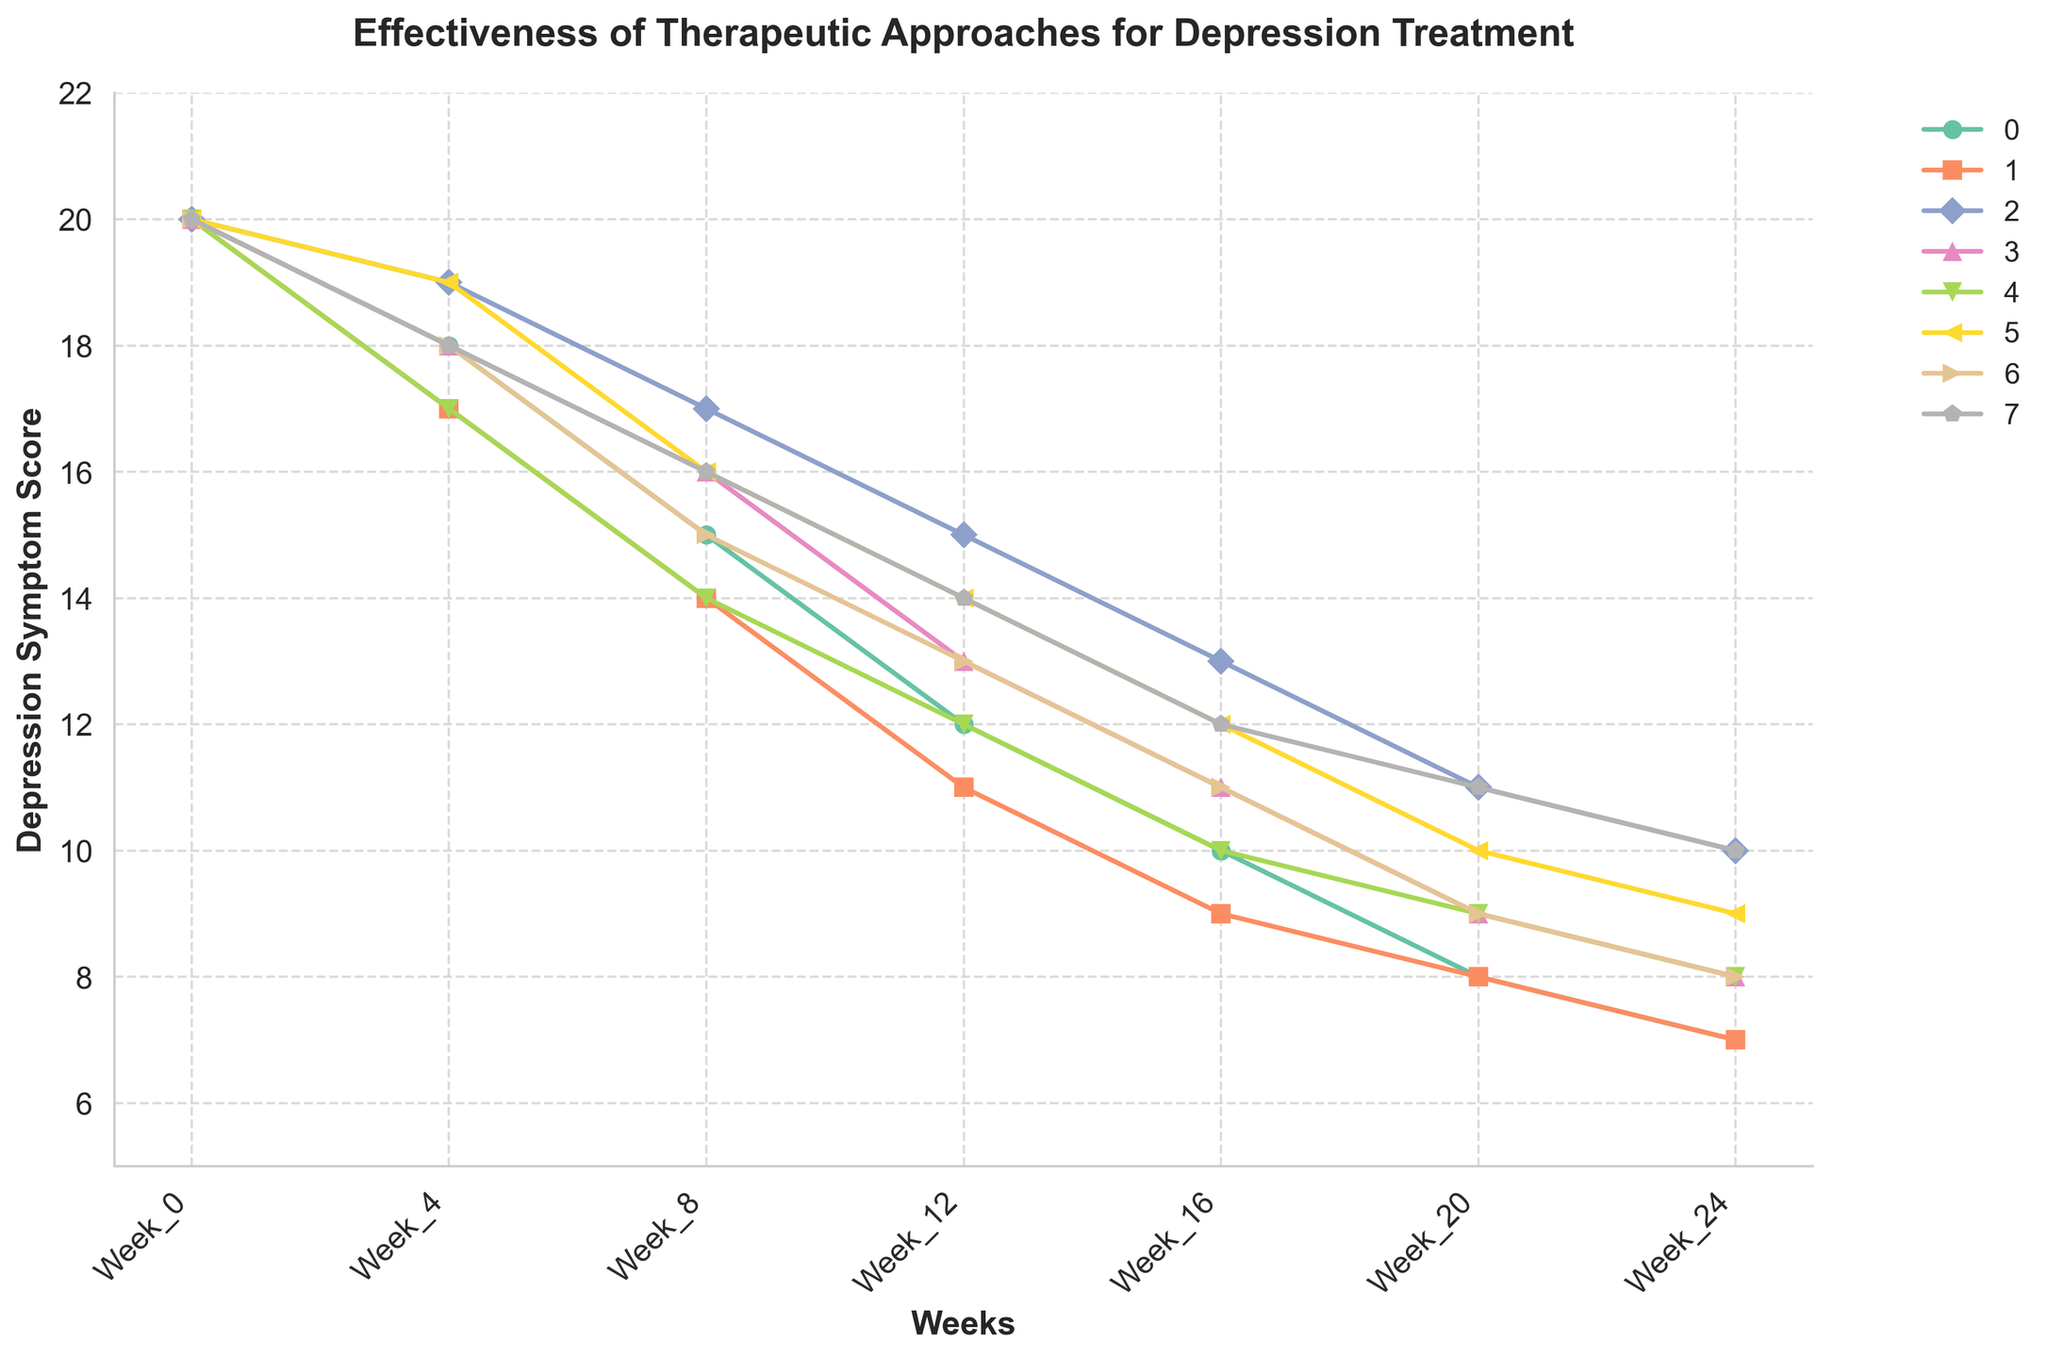What is the general trend observed in all therapeutic approaches over time? The general trend observed in the figure shows that depression symptom scores decrease over time for all therapeutic approaches.
Answer: Decrease over time Which therapy shows the most significant reduction in depression symptoms from Week 0 to Week 24? Cognitive Behavioral Therapy starts at 20 and reduces to 7, showing the most significant reduction (20 - 7 = 13 points).
Answer: Cognitive Behavioral Therapy After 16 weeks, which two therapies have the same depression symptom score, and what is that score? Interpersonal Therapy and Dialectical Behavior Therapy both have a score of 9 at Week 16.
Answer: Interpersonal Therapy, Dialectical Behavior Therapy; 9 Compare the reduction in symptom scores between Behavioral Activation and Psychodynamic Therapy over the entire period. Behavioral Activation reduces from 20 to 8 (20 - 8 = 12), and Psychodynamic Therapy from 20 to 10 (20 - 10 = 10).
Answer: Behavioral Activation: 12, Psychodynamic Therapy: 10 Which therapy has the highest symptom score at Week 24? Psychodynamic Therapy has the highest score at Week 24 with a score of 10.
Answer: Psychodynamic Therapy What is the average reduction in depression symptom scores by Week 12 for all therapies? First find the reductions for each therapy: CBT (20-12=8), IPT (20-11=9), Psychdynamic (20-15=5), MBCT (20-13=7), BA (20-12=8), ACT (20-14=6), DBT (20-13=7), SFBT (20-14=6). Then sum and calculate the average: (8 + 9 + 5 + 7 + 8 + 6 + 7 + 6)/8 = 56/8
Answer: 7 At what week does Acceptance and Commitment Therapy show the same depression symptom score as Mindfulness-Based Cognitive Therapy, and what is that score? Both Acceptance and Commitment Therapy and Mindfulness-Based Cognitive Therapy show a score of 10 at Week 16.
Answer: Week 16; 10 Which therapy shows the least reduction from Week 0 to Week 24? Psychodynamic Therapy shows the least reduction, from 20 to 10, a reduction of 10 points.
Answer: Psychodynamic Therapy By Week 8, how many therapies have reduced their symptom scores to 15 or below? Name them. By Week 8, the therapies that reached 15 or below are CBT (15), IPT (14), BA (14), and DBT (15). So, there are 4 therapies.
Answer: 4; CBT, IPT, BA, DBT How does the symptom reduction of Solution-Focused Brief Therapy compare to Dialectical Behavior Therapy at Week 16? Solution-Focused Brief Therapy has a score of 12, and Dialectical Behavior Therapy has a score of 11 at Week 16, indicating SFBT reduces symptoms by 12 points and DBT by 9.
Answer: SFBT: 12, DBT: 11 